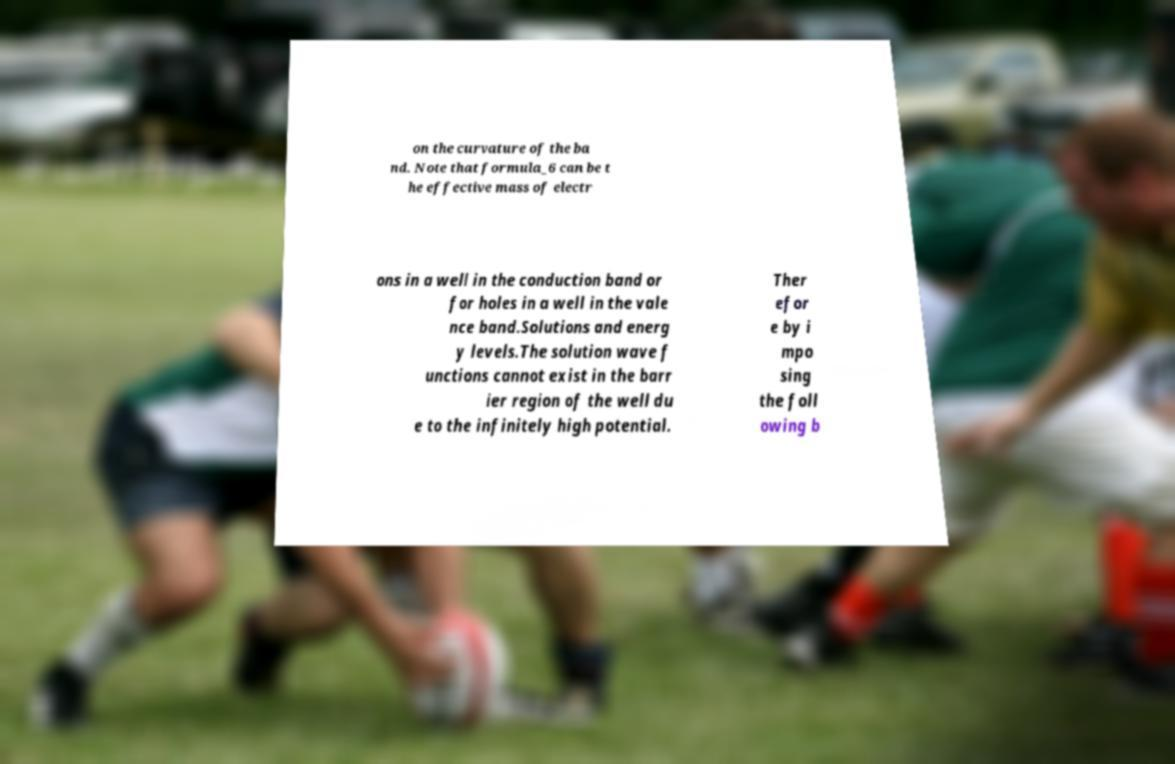Can you read and provide the text displayed in the image?This photo seems to have some interesting text. Can you extract and type it out for me? on the curvature of the ba nd. Note that formula_6 can be t he effective mass of electr ons in a well in the conduction band or for holes in a well in the vale nce band.Solutions and energ y levels.The solution wave f unctions cannot exist in the barr ier region of the well du e to the infinitely high potential. Ther efor e by i mpo sing the foll owing b 